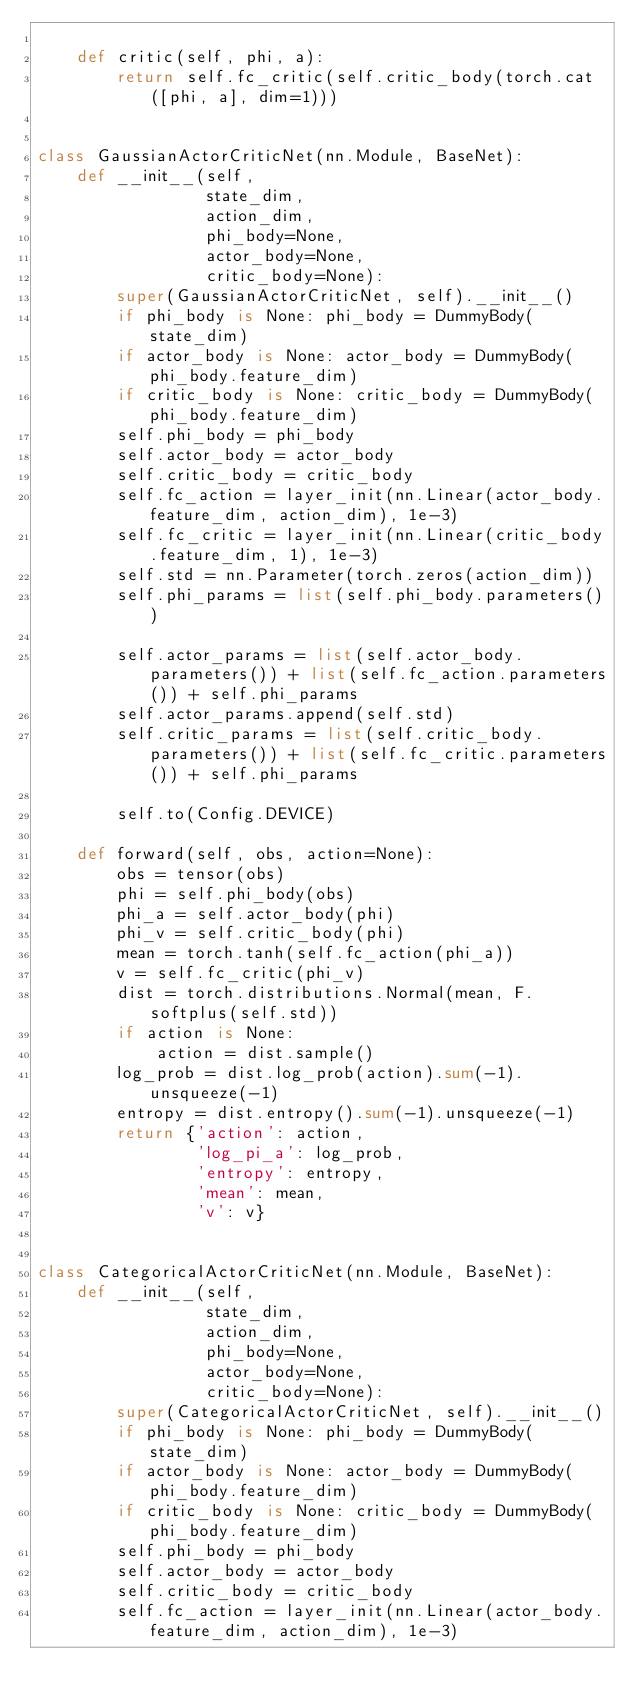Convert code to text. <code><loc_0><loc_0><loc_500><loc_500><_Python_>
    def critic(self, phi, a):
        return self.fc_critic(self.critic_body(torch.cat([phi, a], dim=1)))


class GaussianActorCriticNet(nn.Module, BaseNet):
    def __init__(self,
                 state_dim,
                 action_dim,
                 phi_body=None,
                 actor_body=None,
                 critic_body=None):
        super(GaussianActorCriticNet, self).__init__()
        if phi_body is None: phi_body = DummyBody(state_dim)
        if actor_body is None: actor_body = DummyBody(phi_body.feature_dim)
        if critic_body is None: critic_body = DummyBody(phi_body.feature_dim)
        self.phi_body = phi_body
        self.actor_body = actor_body
        self.critic_body = critic_body
        self.fc_action = layer_init(nn.Linear(actor_body.feature_dim, action_dim), 1e-3)
        self.fc_critic = layer_init(nn.Linear(critic_body.feature_dim, 1), 1e-3)
        self.std = nn.Parameter(torch.zeros(action_dim))
        self.phi_params = list(self.phi_body.parameters())

        self.actor_params = list(self.actor_body.parameters()) + list(self.fc_action.parameters()) + self.phi_params
        self.actor_params.append(self.std)
        self.critic_params = list(self.critic_body.parameters()) + list(self.fc_critic.parameters()) + self.phi_params

        self.to(Config.DEVICE)

    def forward(self, obs, action=None):
        obs = tensor(obs)
        phi = self.phi_body(obs)
        phi_a = self.actor_body(phi)
        phi_v = self.critic_body(phi)
        mean = torch.tanh(self.fc_action(phi_a))
        v = self.fc_critic(phi_v)
        dist = torch.distributions.Normal(mean, F.softplus(self.std))
        if action is None:
            action = dist.sample()
        log_prob = dist.log_prob(action).sum(-1).unsqueeze(-1)
        entropy = dist.entropy().sum(-1).unsqueeze(-1)
        return {'action': action,
                'log_pi_a': log_prob,
                'entropy': entropy,
                'mean': mean,
                'v': v}


class CategoricalActorCriticNet(nn.Module, BaseNet):
    def __init__(self,
                 state_dim,
                 action_dim,
                 phi_body=None,
                 actor_body=None,
                 critic_body=None):
        super(CategoricalActorCriticNet, self).__init__()
        if phi_body is None: phi_body = DummyBody(state_dim)
        if actor_body is None: actor_body = DummyBody(phi_body.feature_dim)
        if critic_body is None: critic_body = DummyBody(phi_body.feature_dim)
        self.phi_body = phi_body
        self.actor_body = actor_body
        self.critic_body = critic_body
        self.fc_action = layer_init(nn.Linear(actor_body.feature_dim, action_dim), 1e-3)</code> 